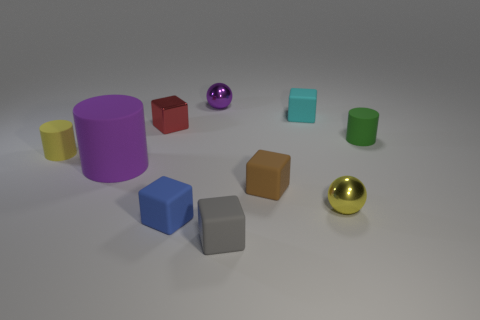Subtract all gray cubes. How many cubes are left? 4 Subtract 1 cylinders. How many cylinders are left? 2 Subtract all small cyan cubes. How many cubes are left? 4 Subtract all red cubes. Subtract all green cylinders. How many cubes are left? 4 Subtract all cylinders. How many objects are left? 7 Subtract all large brown metallic blocks. Subtract all tiny green objects. How many objects are left? 9 Add 9 cyan matte blocks. How many cyan matte blocks are left? 10 Add 7 small cyan metallic blocks. How many small cyan metallic blocks exist? 7 Subtract 1 cyan blocks. How many objects are left? 9 